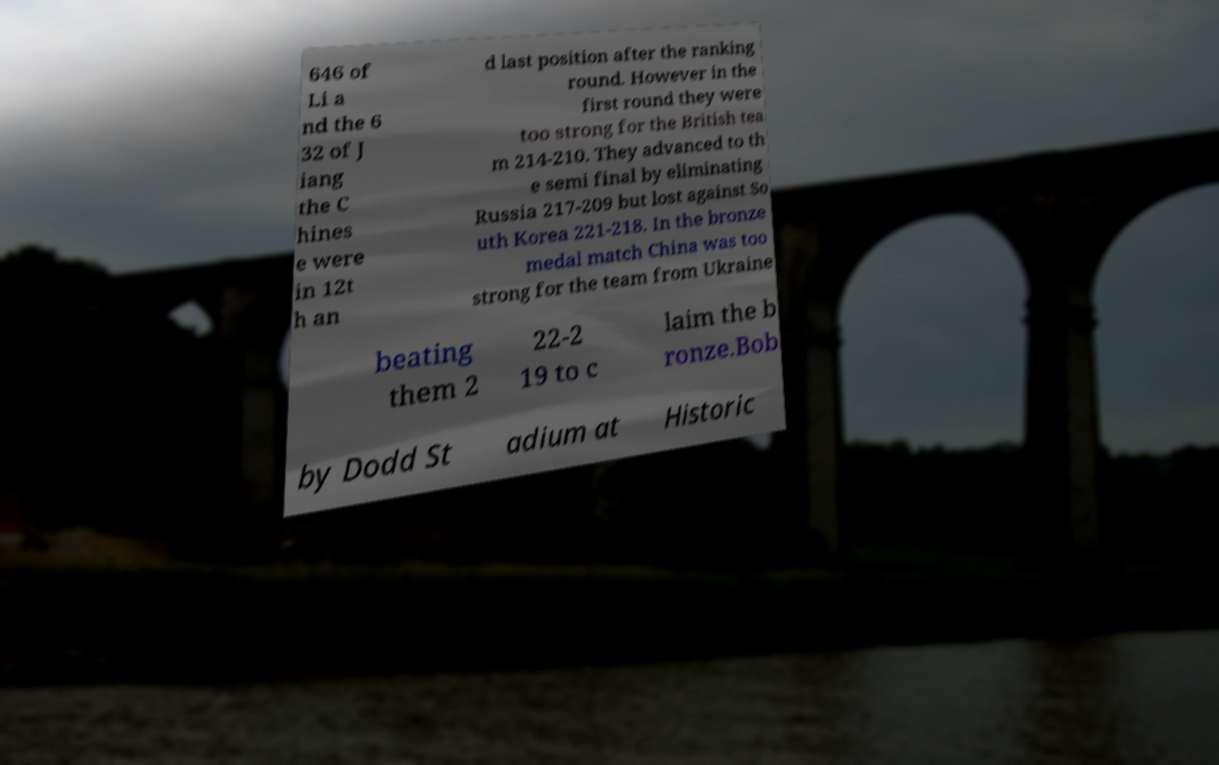For documentation purposes, I need the text within this image transcribed. Could you provide that? 646 of Li a nd the 6 32 of J iang the C hines e were in 12t h an d last position after the ranking round. However in the first round they were too strong for the British tea m 214-210. They advanced to th e semi final by eliminating Russia 217-209 but lost against So uth Korea 221-218. In the bronze medal match China was too strong for the team from Ukraine beating them 2 22-2 19 to c laim the b ronze.Bob by Dodd St adium at Historic 